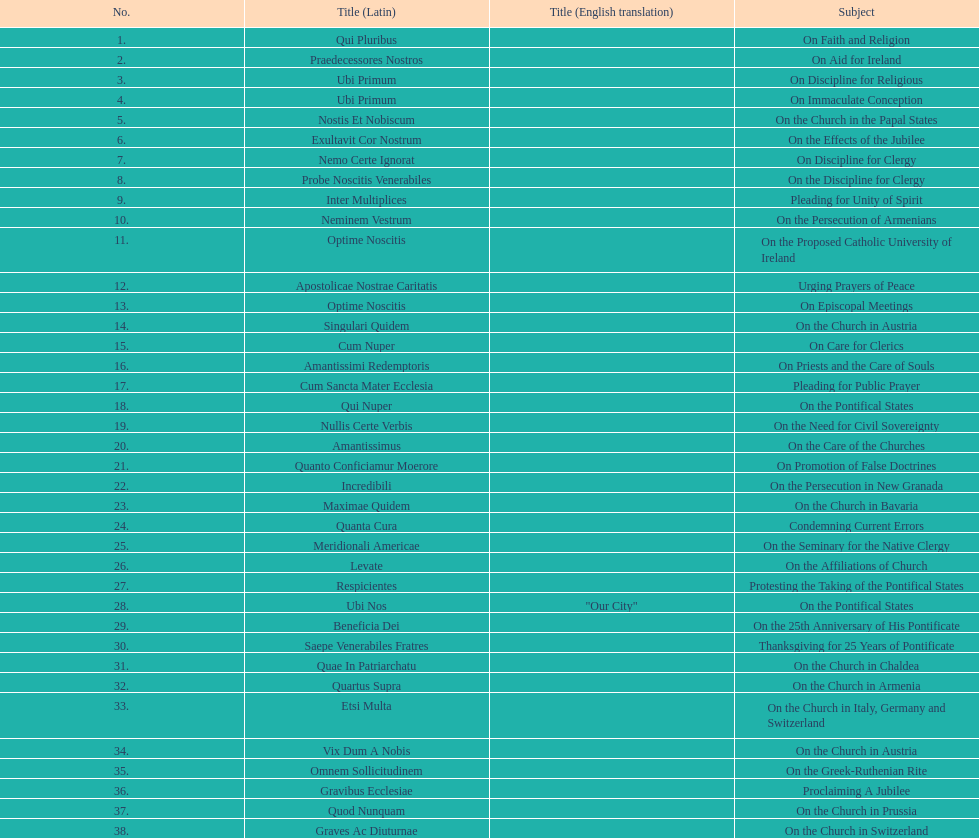Total number of encyclicals on churches . 11. Can you give me this table as a dict? {'header': ['No.', 'Title (Latin)', 'Title (English translation)', 'Subject'], 'rows': [['1.', 'Qui Pluribus', '', 'On Faith and Religion'], ['2.', 'Praedecessores Nostros', '', 'On Aid for Ireland'], ['3.', 'Ubi Primum', '', 'On Discipline for Religious'], ['4.', 'Ubi Primum', '', 'On Immaculate Conception'], ['5.', 'Nostis Et Nobiscum', '', 'On the Church in the Papal States'], ['6.', 'Exultavit Cor Nostrum', '', 'On the Effects of the Jubilee'], ['7.', 'Nemo Certe Ignorat', '', 'On Discipline for Clergy'], ['8.', 'Probe Noscitis Venerabiles', '', 'On the Discipline for Clergy'], ['9.', 'Inter Multiplices', '', 'Pleading for Unity of Spirit'], ['10.', 'Neminem Vestrum', '', 'On the Persecution of Armenians'], ['11.', 'Optime Noscitis', '', 'On the Proposed Catholic University of Ireland'], ['12.', 'Apostolicae Nostrae Caritatis', '', 'Urging Prayers of Peace'], ['13.', 'Optime Noscitis', '', 'On Episcopal Meetings'], ['14.', 'Singulari Quidem', '', 'On the Church in Austria'], ['15.', 'Cum Nuper', '', 'On Care for Clerics'], ['16.', 'Amantissimi Redemptoris', '', 'On Priests and the Care of Souls'], ['17.', 'Cum Sancta Mater Ecclesia', '', 'Pleading for Public Prayer'], ['18.', 'Qui Nuper', '', 'On the Pontifical States'], ['19.', 'Nullis Certe Verbis', '', 'On the Need for Civil Sovereignty'], ['20.', 'Amantissimus', '', 'On the Care of the Churches'], ['21.', 'Quanto Conficiamur Moerore', '', 'On Promotion of False Doctrines'], ['22.', 'Incredibili', '', 'On the Persecution in New Granada'], ['23.', 'Maximae Quidem', '', 'On the Church in Bavaria'], ['24.', 'Quanta Cura', '', 'Condemning Current Errors'], ['25.', 'Meridionali Americae', '', 'On the Seminary for the Native Clergy'], ['26.', 'Levate', '', 'On the Affiliations of Church'], ['27.', 'Respicientes', '', 'Protesting the Taking of the Pontifical States'], ['28.', 'Ubi Nos', '"Our City"', 'On the Pontifical States'], ['29.', 'Beneficia Dei', '', 'On the 25th Anniversary of His Pontificate'], ['30.', 'Saepe Venerabiles Fratres', '', 'Thanksgiving for 25 Years of Pontificate'], ['31.', 'Quae In Patriarchatu', '', 'On the Church in Chaldea'], ['32.', 'Quartus Supra', '', 'On the Church in Armenia'], ['33.', 'Etsi Multa', '', 'On the Church in Italy, Germany and Switzerland'], ['34.', 'Vix Dum A Nobis', '', 'On the Church in Austria'], ['35.', 'Omnem Sollicitudinem', '', 'On the Greek-Ruthenian Rite'], ['36.', 'Gravibus Ecclesiae', '', 'Proclaiming A Jubilee'], ['37.', 'Quod Nunquam', '', 'On the Church in Prussia'], ['38.', 'Graves Ac Diuturnae', '', 'On the Church in Switzerland']]} 